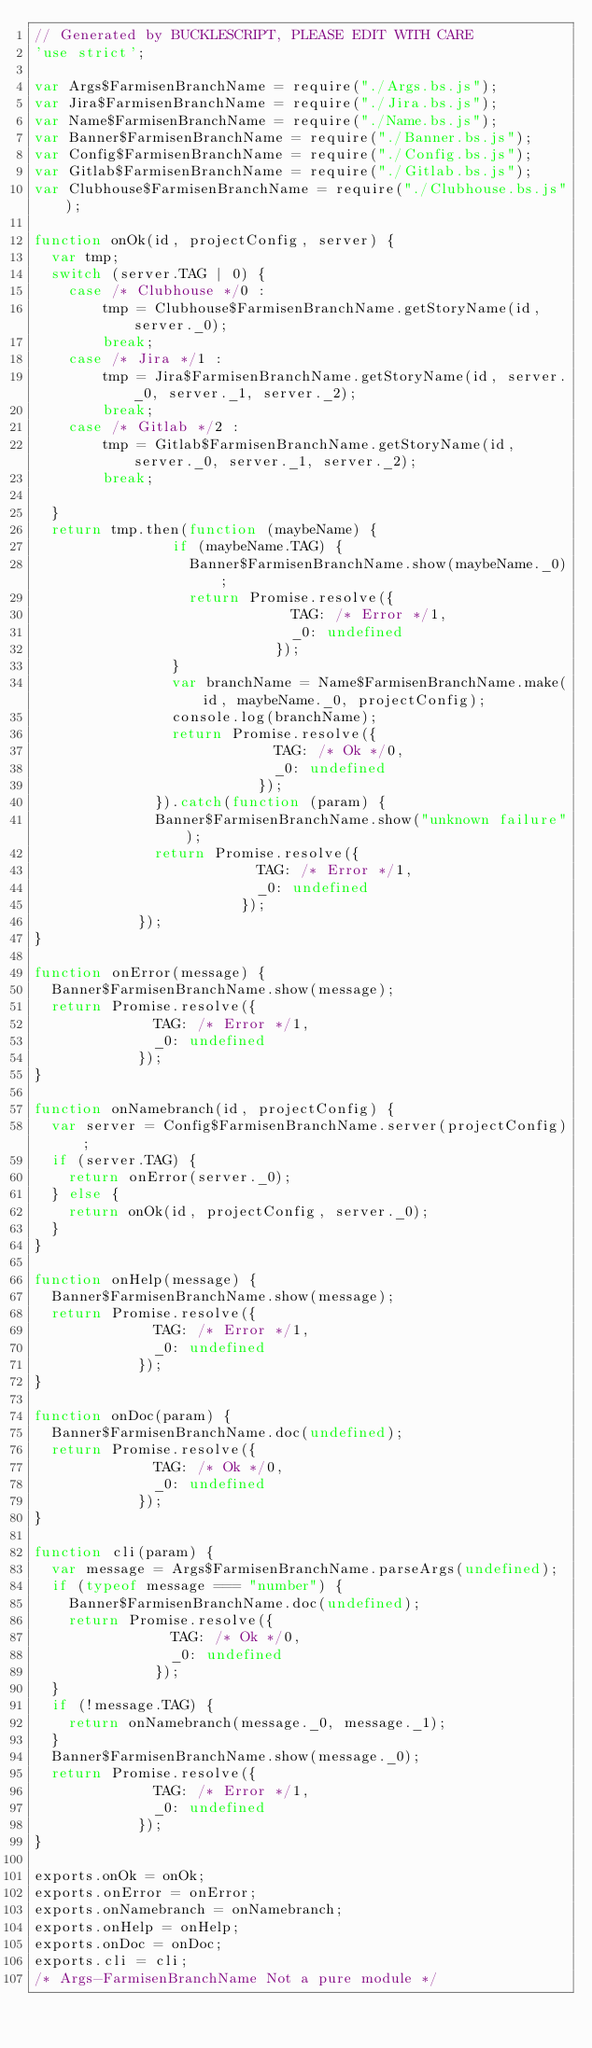Convert code to text. <code><loc_0><loc_0><loc_500><loc_500><_JavaScript_>// Generated by BUCKLESCRIPT, PLEASE EDIT WITH CARE
'use strict';

var Args$FarmisenBranchName = require("./Args.bs.js");
var Jira$FarmisenBranchName = require("./Jira.bs.js");
var Name$FarmisenBranchName = require("./Name.bs.js");
var Banner$FarmisenBranchName = require("./Banner.bs.js");
var Config$FarmisenBranchName = require("./Config.bs.js");
var Gitlab$FarmisenBranchName = require("./Gitlab.bs.js");
var Clubhouse$FarmisenBranchName = require("./Clubhouse.bs.js");

function onOk(id, projectConfig, server) {
  var tmp;
  switch (server.TAG | 0) {
    case /* Clubhouse */0 :
        tmp = Clubhouse$FarmisenBranchName.getStoryName(id, server._0);
        break;
    case /* Jira */1 :
        tmp = Jira$FarmisenBranchName.getStoryName(id, server._0, server._1, server._2);
        break;
    case /* Gitlab */2 :
        tmp = Gitlab$FarmisenBranchName.getStoryName(id, server._0, server._1, server._2);
        break;
    
  }
  return tmp.then(function (maybeName) {
                if (maybeName.TAG) {
                  Banner$FarmisenBranchName.show(maybeName._0);
                  return Promise.resolve({
                              TAG: /* Error */1,
                              _0: undefined
                            });
                }
                var branchName = Name$FarmisenBranchName.make(id, maybeName._0, projectConfig);
                console.log(branchName);
                return Promise.resolve({
                            TAG: /* Ok */0,
                            _0: undefined
                          });
              }).catch(function (param) {
              Banner$FarmisenBranchName.show("unknown failure");
              return Promise.resolve({
                          TAG: /* Error */1,
                          _0: undefined
                        });
            });
}

function onError(message) {
  Banner$FarmisenBranchName.show(message);
  return Promise.resolve({
              TAG: /* Error */1,
              _0: undefined
            });
}

function onNamebranch(id, projectConfig) {
  var server = Config$FarmisenBranchName.server(projectConfig);
  if (server.TAG) {
    return onError(server._0);
  } else {
    return onOk(id, projectConfig, server._0);
  }
}

function onHelp(message) {
  Banner$FarmisenBranchName.show(message);
  return Promise.resolve({
              TAG: /* Error */1,
              _0: undefined
            });
}

function onDoc(param) {
  Banner$FarmisenBranchName.doc(undefined);
  return Promise.resolve({
              TAG: /* Ok */0,
              _0: undefined
            });
}

function cli(param) {
  var message = Args$FarmisenBranchName.parseArgs(undefined);
  if (typeof message === "number") {
    Banner$FarmisenBranchName.doc(undefined);
    return Promise.resolve({
                TAG: /* Ok */0,
                _0: undefined
              });
  }
  if (!message.TAG) {
    return onNamebranch(message._0, message._1);
  }
  Banner$FarmisenBranchName.show(message._0);
  return Promise.resolve({
              TAG: /* Error */1,
              _0: undefined
            });
}

exports.onOk = onOk;
exports.onError = onError;
exports.onNamebranch = onNamebranch;
exports.onHelp = onHelp;
exports.onDoc = onDoc;
exports.cli = cli;
/* Args-FarmisenBranchName Not a pure module */
</code> 